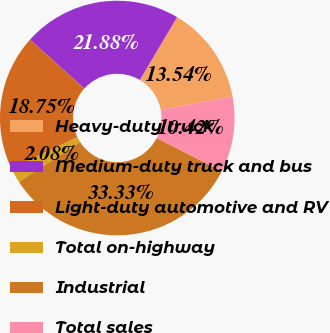Convert chart to OTSL. <chart><loc_0><loc_0><loc_500><loc_500><pie_chart><fcel>Heavy-duty truck<fcel>Medium-duty truck and bus<fcel>Light-duty automotive and RV<fcel>Total on-highway<fcel>Industrial<fcel>Total sales<nl><fcel>13.54%<fcel>21.88%<fcel>18.75%<fcel>2.08%<fcel>33.33%<fcel>10.42%<nl></chart> 